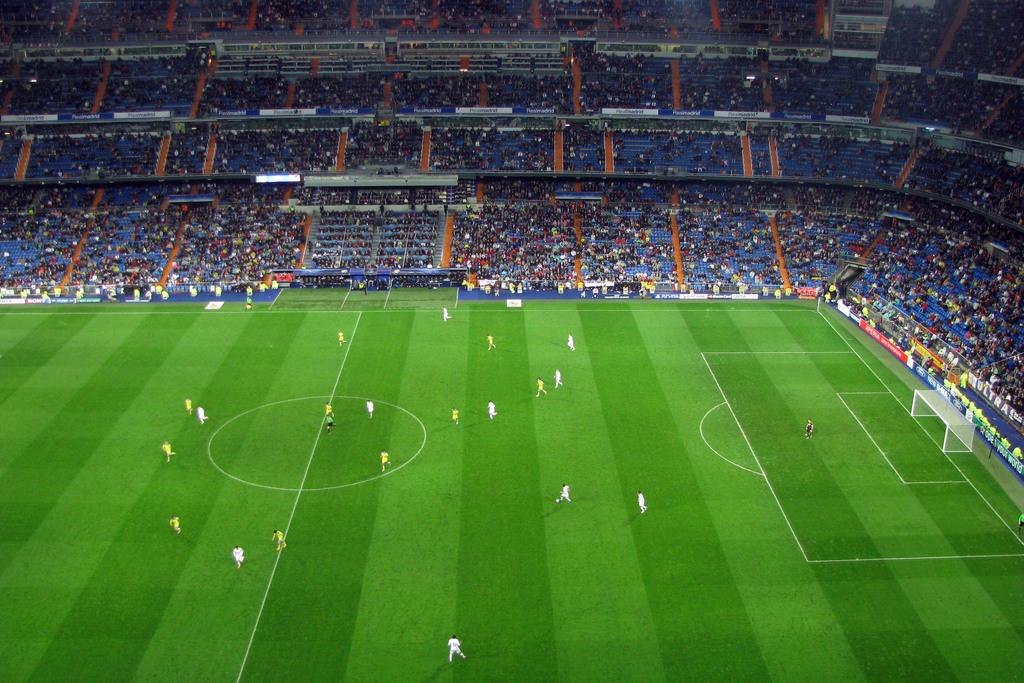What type of venue is depicted in the image? There is a football stadium in the image. Are there any people present in the image? Yes, there are people in the image. What are some people doing in the image? Some people are on the pitch. What can be seen on the field in the image? White lines are visible in the image. What is a key feature of a football field that can be seen in the image? There is a goalpost in the image. What type of toothpaste is being used by the committee in the image? There is no committee or toothpaste present in the image. 